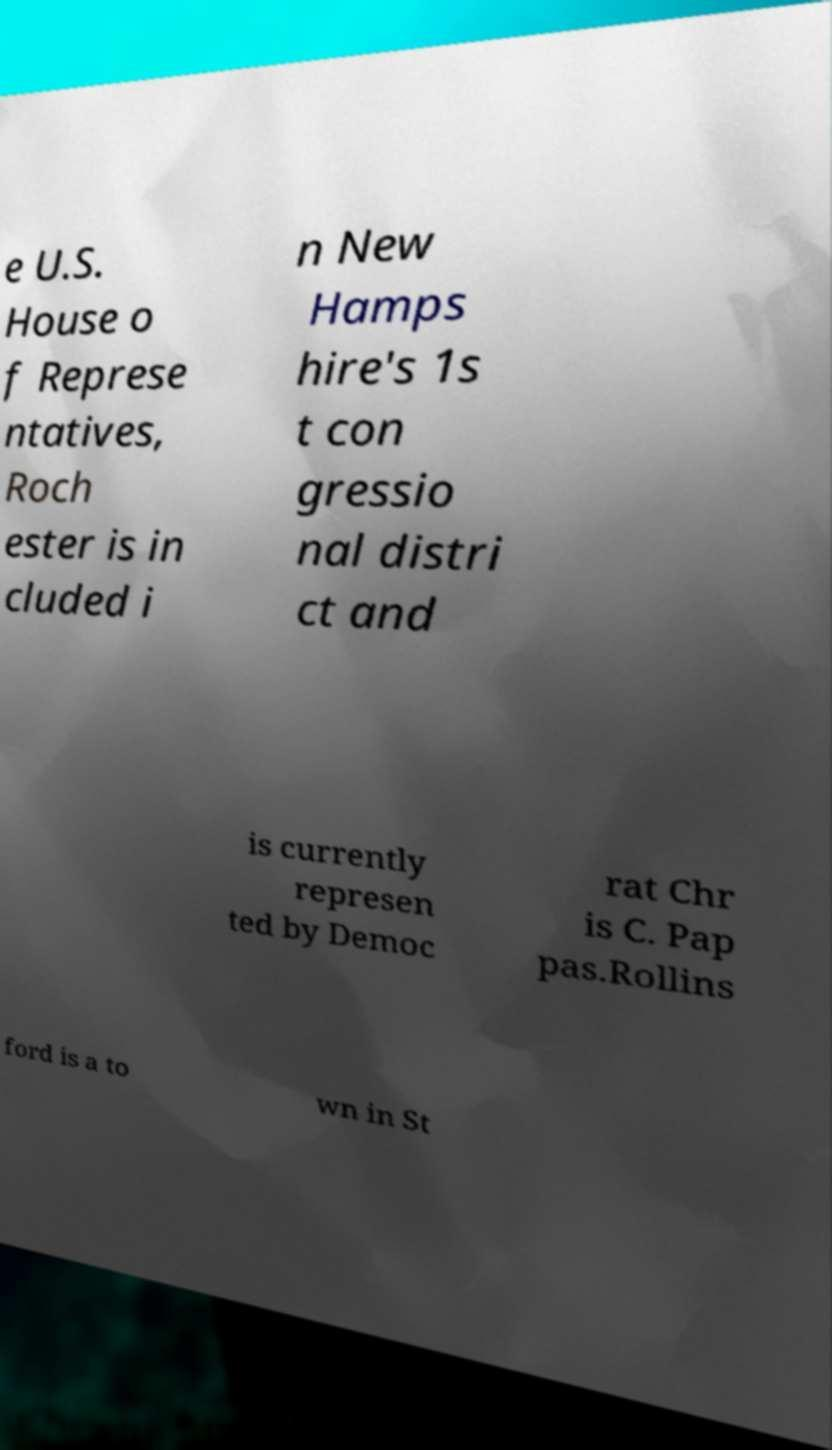Could you assist in decoding the text presented in this image and type it out clearly? e U.S. House o f Represe ntatives, Roch ester is in cluded i n New Hamps hire's 1s t con gressio nal distri ct and is currently represen ted by Democ rat Chr is C. Pap pas.Rollins ford is a to wn in St 